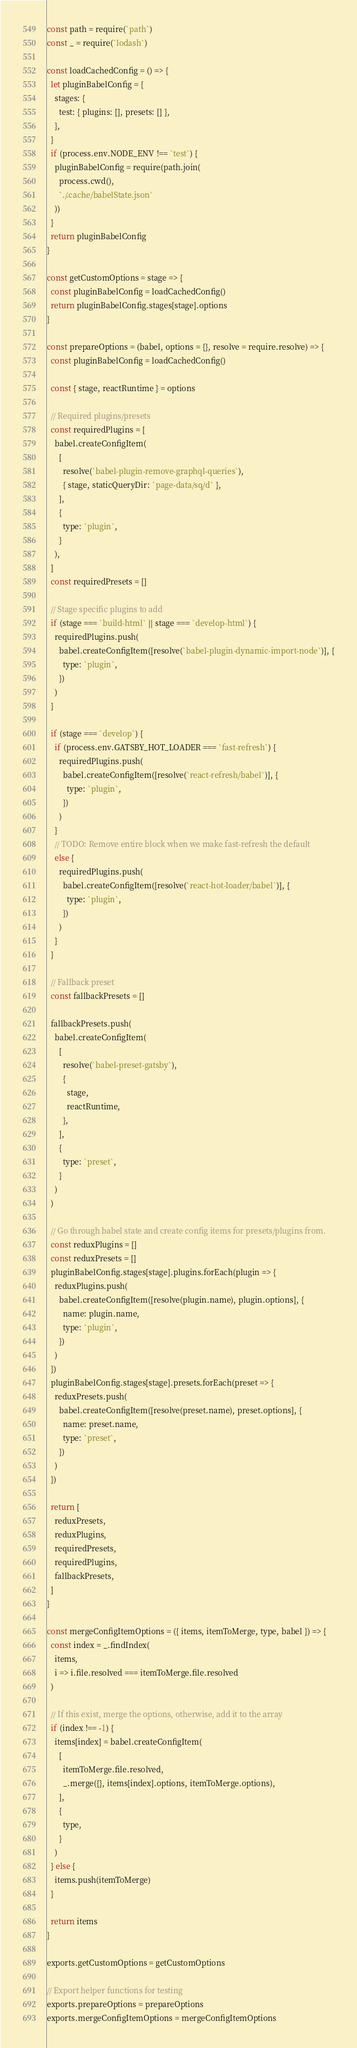Convert code to text. <code><loc_0><loc_0><loc_500><loc_500><_JavaScript_>const path = require(`path`)
const _ = require(`lodash`)

const loadCachedConfig = () => {
  let pluginBabelConfig = {
    stages: {
      test: { plugins: [], presets: [] },
    },
  }
  if (process.env.NODE_ENV !== `test`) {
    pluginBabelConfig = require(path.join(
      process.cwd(),
      `./.cache/babelState.json`
    ))
  }
  return pluginBabelConfig
}

const getCustomOptions = stage => {
  const pluginBabelConfig = loadCachedConfig()
  return pluginBabelConfig.stages[stage].options
}

const prepareOptions = (babel, options = {}, resolve = require.resolve) => {
  const pluginBabelConfig = loadCachedConfig()

  const { stage, reactRuntime } = options

  // Required plugins/presets
  const requiredPlugins = [
    babel.createConfigItem(
      [
        resolve(`babel-plugin-remove-graphql-queries`),
        { stage, staticQueryDir: `page-data/sq/d` },
      ],
      {
        type: `plugin`,
      }
    ),
  ]
  const requiredPresets = []

  // Stage specific plugins to add
  if (stage === `build-html` || stage === `develop-html`) {
    requiredPlugins.push(
      babel.createConfigItem([resolve(`babel-plugin-dynamic-import-node`)], {
        type: `plugin`,
      })
    )
  }

  if (stage === `develop`) {
    if (process.env.GATSBY_HOT_LOADER === `fast-refresh`) {
      requiredPlugins.push(
        babel.createConfigItem([resolve(`react-refresh/babel`)], {
          type: `plugin`,
        })
      )
    }
    // TODO: Remove entire block when we make fast-refresh the default
    else {
      requiredPlugins.push(
        babel.createConfigItem([resolve(`react-hot-loader/babel`)], {
          type: `plugin`,
        })
      )
    }
  }

  // Fallback preset
  const fallbackPresets = []

  fallbackPresets.push(
    babel.createConfigItem(
      [
        resolve(`babel-preset-gatsby`),
        {
          stage,
          reactRuntime,
        },
      ],
      {
        type: `preset`,
      }
    )
  )

  // Go through babel state and create config items for presets/plugins from.
  const reduxPlugins = []
  const reduxPresets = []
  pluginBabelConfig.stages[stage].plugins.forEach(plugin => {
    reduxPlugins.push(
      babel.createConfigItem([resolve(plugin.name), plugin.options], {
        name: plugin.name,
        type: `plugin`,
      })
    )
  })
  pluginBabelConfig.stages[stage].presets.forEach(preset => {
    reduxPresets.push(
      babel.createConfigItem([resolve(preset.name), preset.options], {
        name: preset.name,
        type: `preset`,
      })
    )
  })

  return [
    reduxPresets,
    reduxPlugins,
    requiredPresets,
    requiredPlugins,
    fallbackPresets,
  ]
}

const mergeConfigItemOptions = ({ items, itemToMerge, type, babel }) => {
  const index = _.findIndex(
    items,
    i => i.file.resolved === itemToMerge.file.resolved
  )

  // If this exist, merge the options, otherwise, add it to the array
  if (index !== -1) {
    items[index] = babel.createConfigItem(
      [
        itemToMerge.file.resolved,
        _.merge({}, items[index].options, itemToMerge.options),
      ],
      {
        type,
      }
    )
  } else {
    items.push(itemToMerge)
  }

  return items
}

exports.getCustomOptions = getCustomOptions

// Export helper functions for testing
exports.prepareOptions = prepareOptions
exports.mergeConfigItemOptions = mergeConfigItemOptions
</code> 